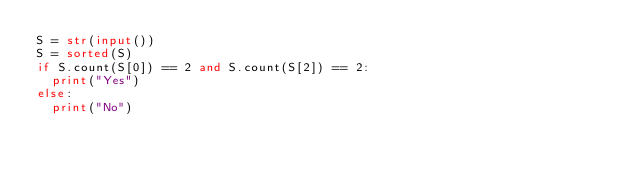Convert code to text. <code><loc_0><loc_0><loc_500><loc_500><_Python_>S = str(input())
S = sorted(S)
if S.count(S[0]) == 2 and S.count(S[2]) == 2:
  print("Yes")
else:
  print("No")</code> 